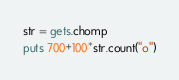Convert code to text. <code><loc_0><loc_0><loc_500><loc_500><_Ruby_>str = gets.chomp
puts 700+100*str.count("o")</code> 